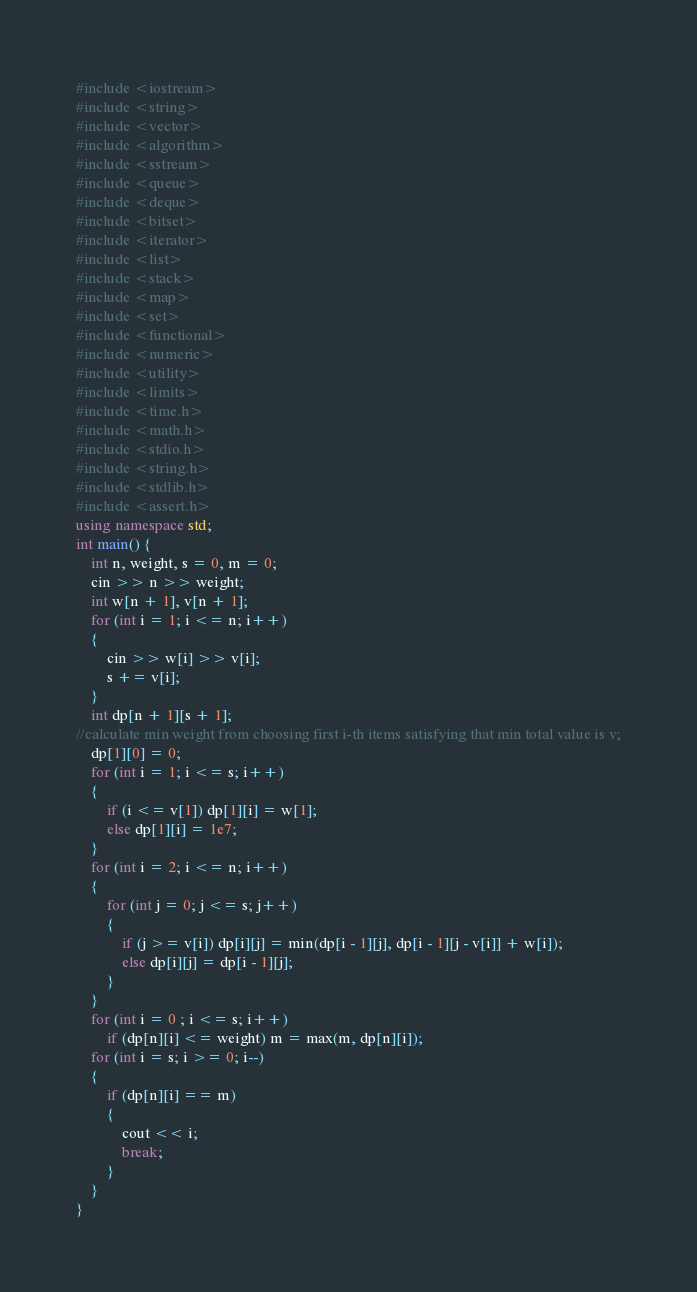Convert code to text. <code><loc_0><loc_0><loc_500><loc_500><_C++_>#include <iostream>
#include <string>
#include <vector>
#include <algorithm>
#include <sstream>
#include <queue>
#include <deque>
#include <bitset>
#include <iterator>
#include <list>
#include <stack>
#include <map>
#include <set>
#include <functional>
#include <numeric>
#include <utility>
#include <limits>
#include <time.h>
#include <math.h>
#include <stdio.h>
#include <string.h>
#include <stdlib.h>
#include <assert.h>
using namespace std;
int main() {
    int n, weight, s = 0, m = 0;
    cin >> n >> weight;
    int w[n + 1], v[n + 1];
    for (int i = 1; i <= n; i++) 
    {
        cin >> w[i] >> v[i];
        s += v[i];
    }
    int dp[n + 1][s + 1];
//calculate min weight from choosing first i-th items satisfying that min total value is v;
    dp[1][0] = 0;
    for (int i = 1; i <= s; i++)
    {
    	if (i <= v[1]) dp[1][i] = w[1];
    	else dp[1][i] = 1e7;
    }
    for (int i = 2; i <= n; i++)
    {
    	for (int j = 0; j <= s; j++)
    	{
    		if (j >= v[i]) dp[i][j] = min(dp[i - 1][j], dp[i - 1][j - v[i]] + w[i]);
    		else dp[i][j] = dp[i - 1][j];
    	}
    }
    for (int i = 0 ; i <= s; i++)
        if (dp[n][i] <= weight) m = max(m, dp[n][i]);
    for (int i = s; i >= 0; i--)
    {
        if (dp[n][i] == m)
        {
            cout << i;
            break;
        }
    }
}</code> 